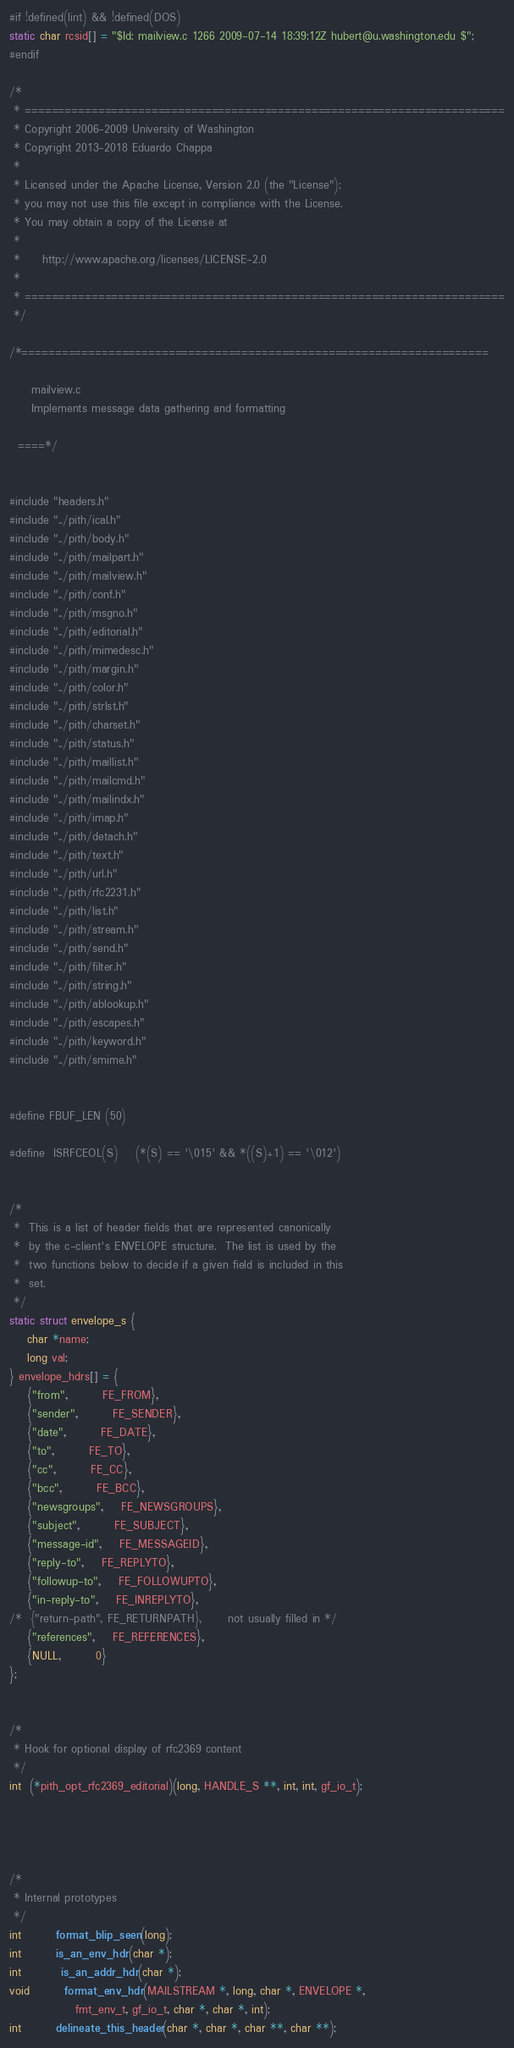Convert code to text. <code><loc_0><loc_0><loc_500><loc_500><_C_>#if !defined(lint) && !defined(DOS)
static char rcsid[] = "$Id: mailview.c 1266 2009-07-14 18:39:12Z hubert@u.washington.edu $";
#endif

/*
 * ========================================================================
 * Copyright 2006-2009 University of Washington
 * Copyright 2013-2018 Eduardo Chappa
 *
 * Licensed under the Apache License, Version 2.0 (the "License");
 * you may not use this file except in compliance with the License.
 * You may obtain a copy of the License at
 *
 *     http://www.apache.org/licenses/LICENSE-2.0
 *
 * ========================================================================
 */

/*======================================================================

     mailview.c
     Implements message data gathering and formatting

  ====*/


#include "headers.h"
#include "../pith/ical.h"
#include "../pith/body.h"
#include "../pith/mailpart.h"
#include "../pith/mailview.h"
#include "../pith/conf.h"
#include "../pith/msgno.h"
#include "../pith/editorial.h"
#include "../pith/mimedesc.h"
#include "../pith/margin.h"
#include "../pith/color.h"
#include "../pith/strlst.h"
#include "../pith/charset.h"
#include "../pith/status.h"
#include "../pith/maillist.h"
#include "../pith/mailcmd.h"
#include "../pith/mailindx.h"
#include "../pith/imap.h"
#include "../pith/detach.h"
#include "../pith/text.h"
#include "../pith/url.h"
#include "../pith/rfc2231.h"
#include "../pith/list.h"
#include "../pith/stream.h"
#include "../pith/send.h"
#include "../pith/filter.h"
#include "../pith/string.h"
#include "../pith/ablookup.h"
#include "../pith/escapes.h"
#include "../pith/keyword.h"
#include "../pith/smime.h"


#define FBUF_LEN	(50)

#define	ISRFCEOL(S)    (*(S) == '\015' && *((S)+1) == '\012')


/*
 *  This is a list of header fields that are represented canonically
 *  by the c-client's ENVELOPE structure.  The list is used by the
 *  two functions below to decide if a given field is included in this
 *  set.
 */
static struct envelope_s {
    char *name;
    long val;
} envelope_hdrs[] = {
    {"from",		FE_FROM},
    {"sender",		FE_SENDER},
    {"date",		FE_DATE},
    {"to",		FE_TO},
    {"cc",		FE_CC},
    {"bcc",		FE_BCC},
    {"newsgroups",	FE_NEWSGROUPS},
    {"subject",		FE_SUBJECT},
    {"message-id",	FE_MESSAGEID},
    {"reply-to",	FE_REPLYTO},
    {"followup-to",	FE_FOLLOWUPTO},
    {"in-reply-to",	FE_INREPLYTO},
/*  {"return-path",	FE_RETURNPATH},      not usually filled in */
    {"references",	FE_REFERENCES},
    {NULL,		0}
};


/*
 * Hook for optional display of rfc2369 content
 */
int  (*pith_opt_rfc2369_editorial)(long, HANDLE_S **, int, int, gf_io_t);




/*
 * Internal prototypes
 */
int	    format_blip_seen(long);
int	    is_an_env_hdr(char *);
int         is_an_addr_hdr(char *);
void	    format_env_hdr(MAILSTREAM *, long, char *, ENVELOPE *,
			   fmt_env_t, gf_io_t, char *, char *, int);
int	    delineate_this_header(char *, char *, char **, char **);</code> 